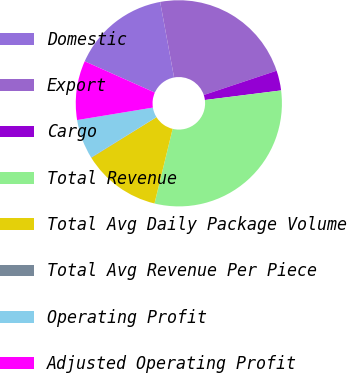<chart> <loc_0><loc_0><loc_500><loc_500><pie_chart><fcel>Domestic<fcel>Export<fcel>Cargo<fcel>Total Revenue<fcel>Total Avg Daily Package Volume<fcel>Total Avg Revenue Per Piece<fcel>Operating Profit<fcel>Adjusted Operating Profit<nl><fcel>15.42%<fcel>22.78%<fcel>3.13%<fcel>30.79%<fcel>12.35%<fcel>0.06%<fcel>6.2%<fcel>9.28%<nl></chart> 